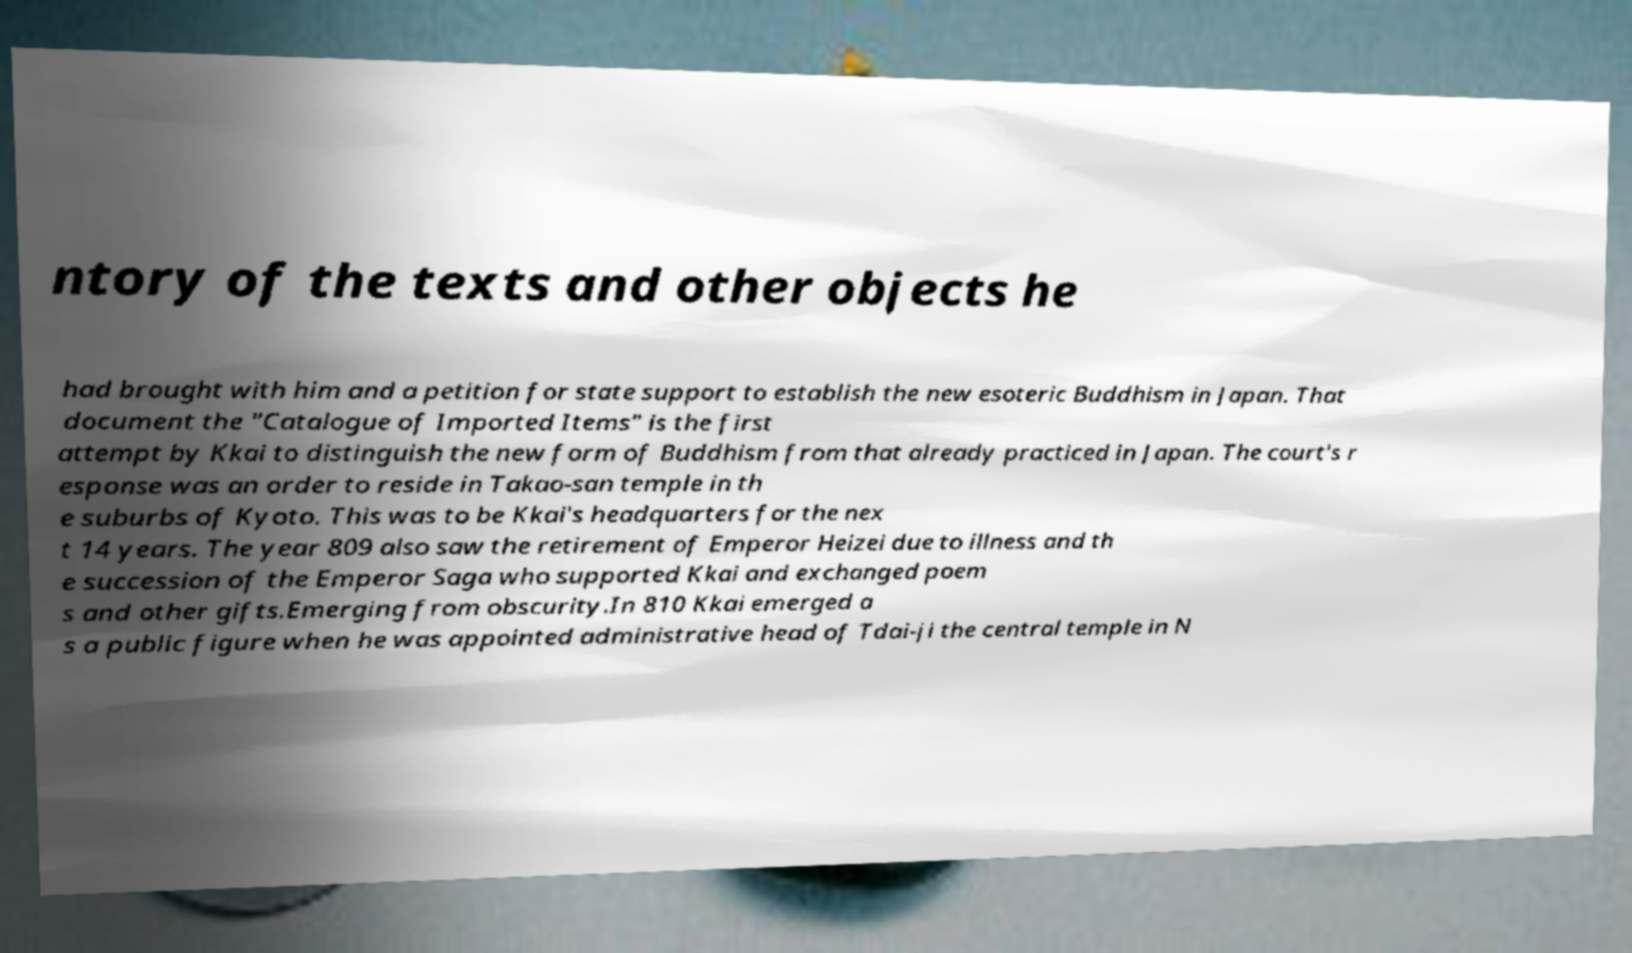Could you extract and type out the text from this image? ntory of the texts and other objects he had brought with him and a petition for state support to establish the new esoteric Buddhism in Japan. That document the "Catalogue of Imported Items" is the first attempt by Kkai to distinguish the new form of Buddhism from that already practiced in Japan. The court's r esponse was an order to reside in Takao-san temple in th e suburbs of Kyoto. This was to be Kkai's headquarters for the nex t 14 years. The year 809 also saw the retirement of Emperor Heizei due to illness and th e succession of the Emperor Saga who supported Kkai and exchanged poem s and other gifts.Emerging from obscurity.In 810 Kkai emerged a s a public figure when he was appointed administrative head of Tdai-ji the central temple in N 